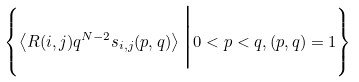<formula> <loc_0><loc_0><loc_500><loc_500>\left \{ \left < R ( i , j ) q ^ { N - 2 } s _ { i , j } ( p , q ) \right > \Big | 0 < p < q , ( p , q ) = 1 \right \}</formula> 